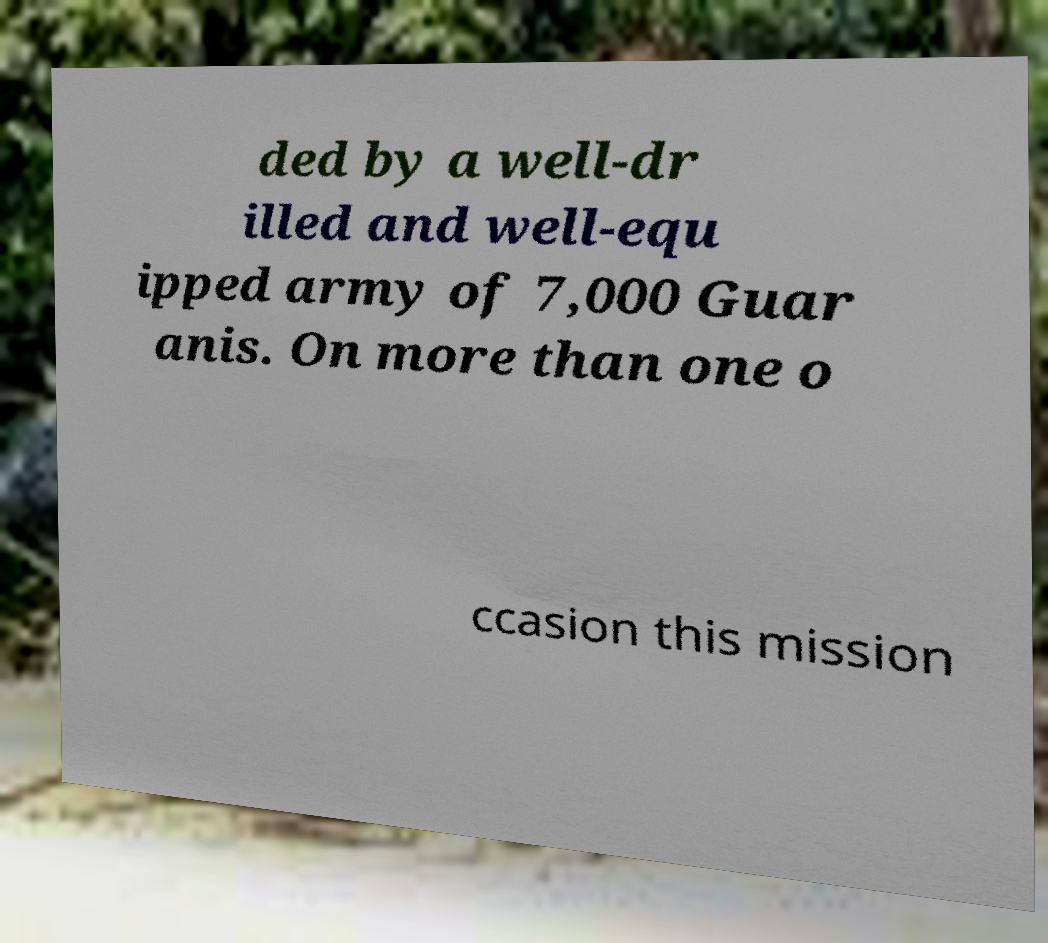What messages or text are displayed in this image? I need them in a readable, typed format. ded by a well-dr illed and well-equ ipped army of 7,000 Guar anis. On more than one o ccasion this mission 